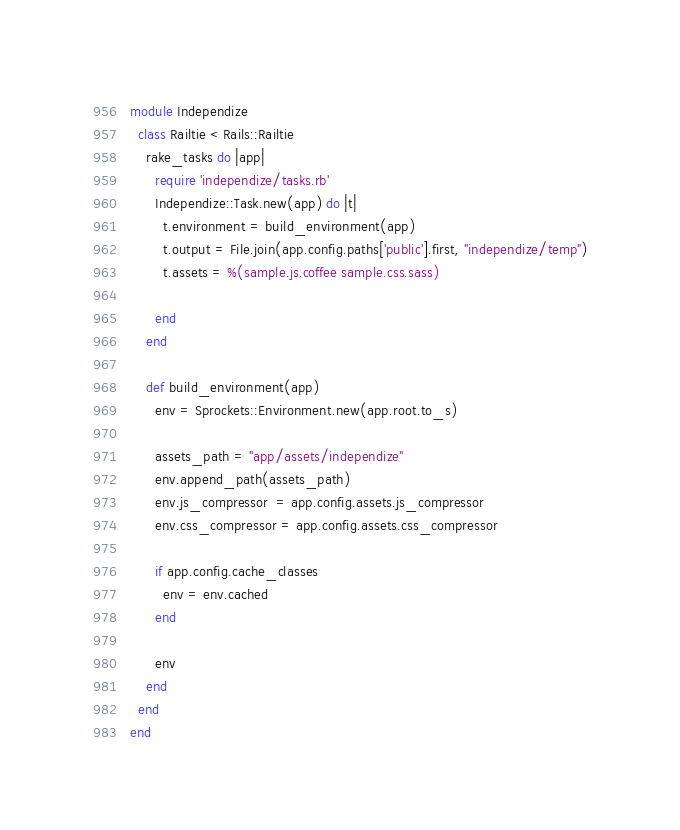Convert code to text. <code><loc_0><loc_0><loc_500><loc_500><_Ruby_>module Independize
  class Railtie < Rails::Railtie
    rake_tasks do |app|
      require 'independize/tasks.rb'
      Independize::Task.new(app) do |t|
        t.environment = build_environment(app)
        t.output = File.join(app.config.paths['public'].first, "independize/temp")
        t.assets = %(sample.js.coffee sample.css.sass)

      end
    end

    def build_environment(app)
      env = Sprockets::Environment.new(app.root.to_s)

      assets_path = "app/assets/independize"
      env.append_path(assets_path)
      env.js_compressor  = app.config.assets.js_compressor
      env.css_compressor = app.config.assets.css_compressor

      if app.config.cache_classes
        env = env.cached
      end

      env
    end
  end
end
</code> 